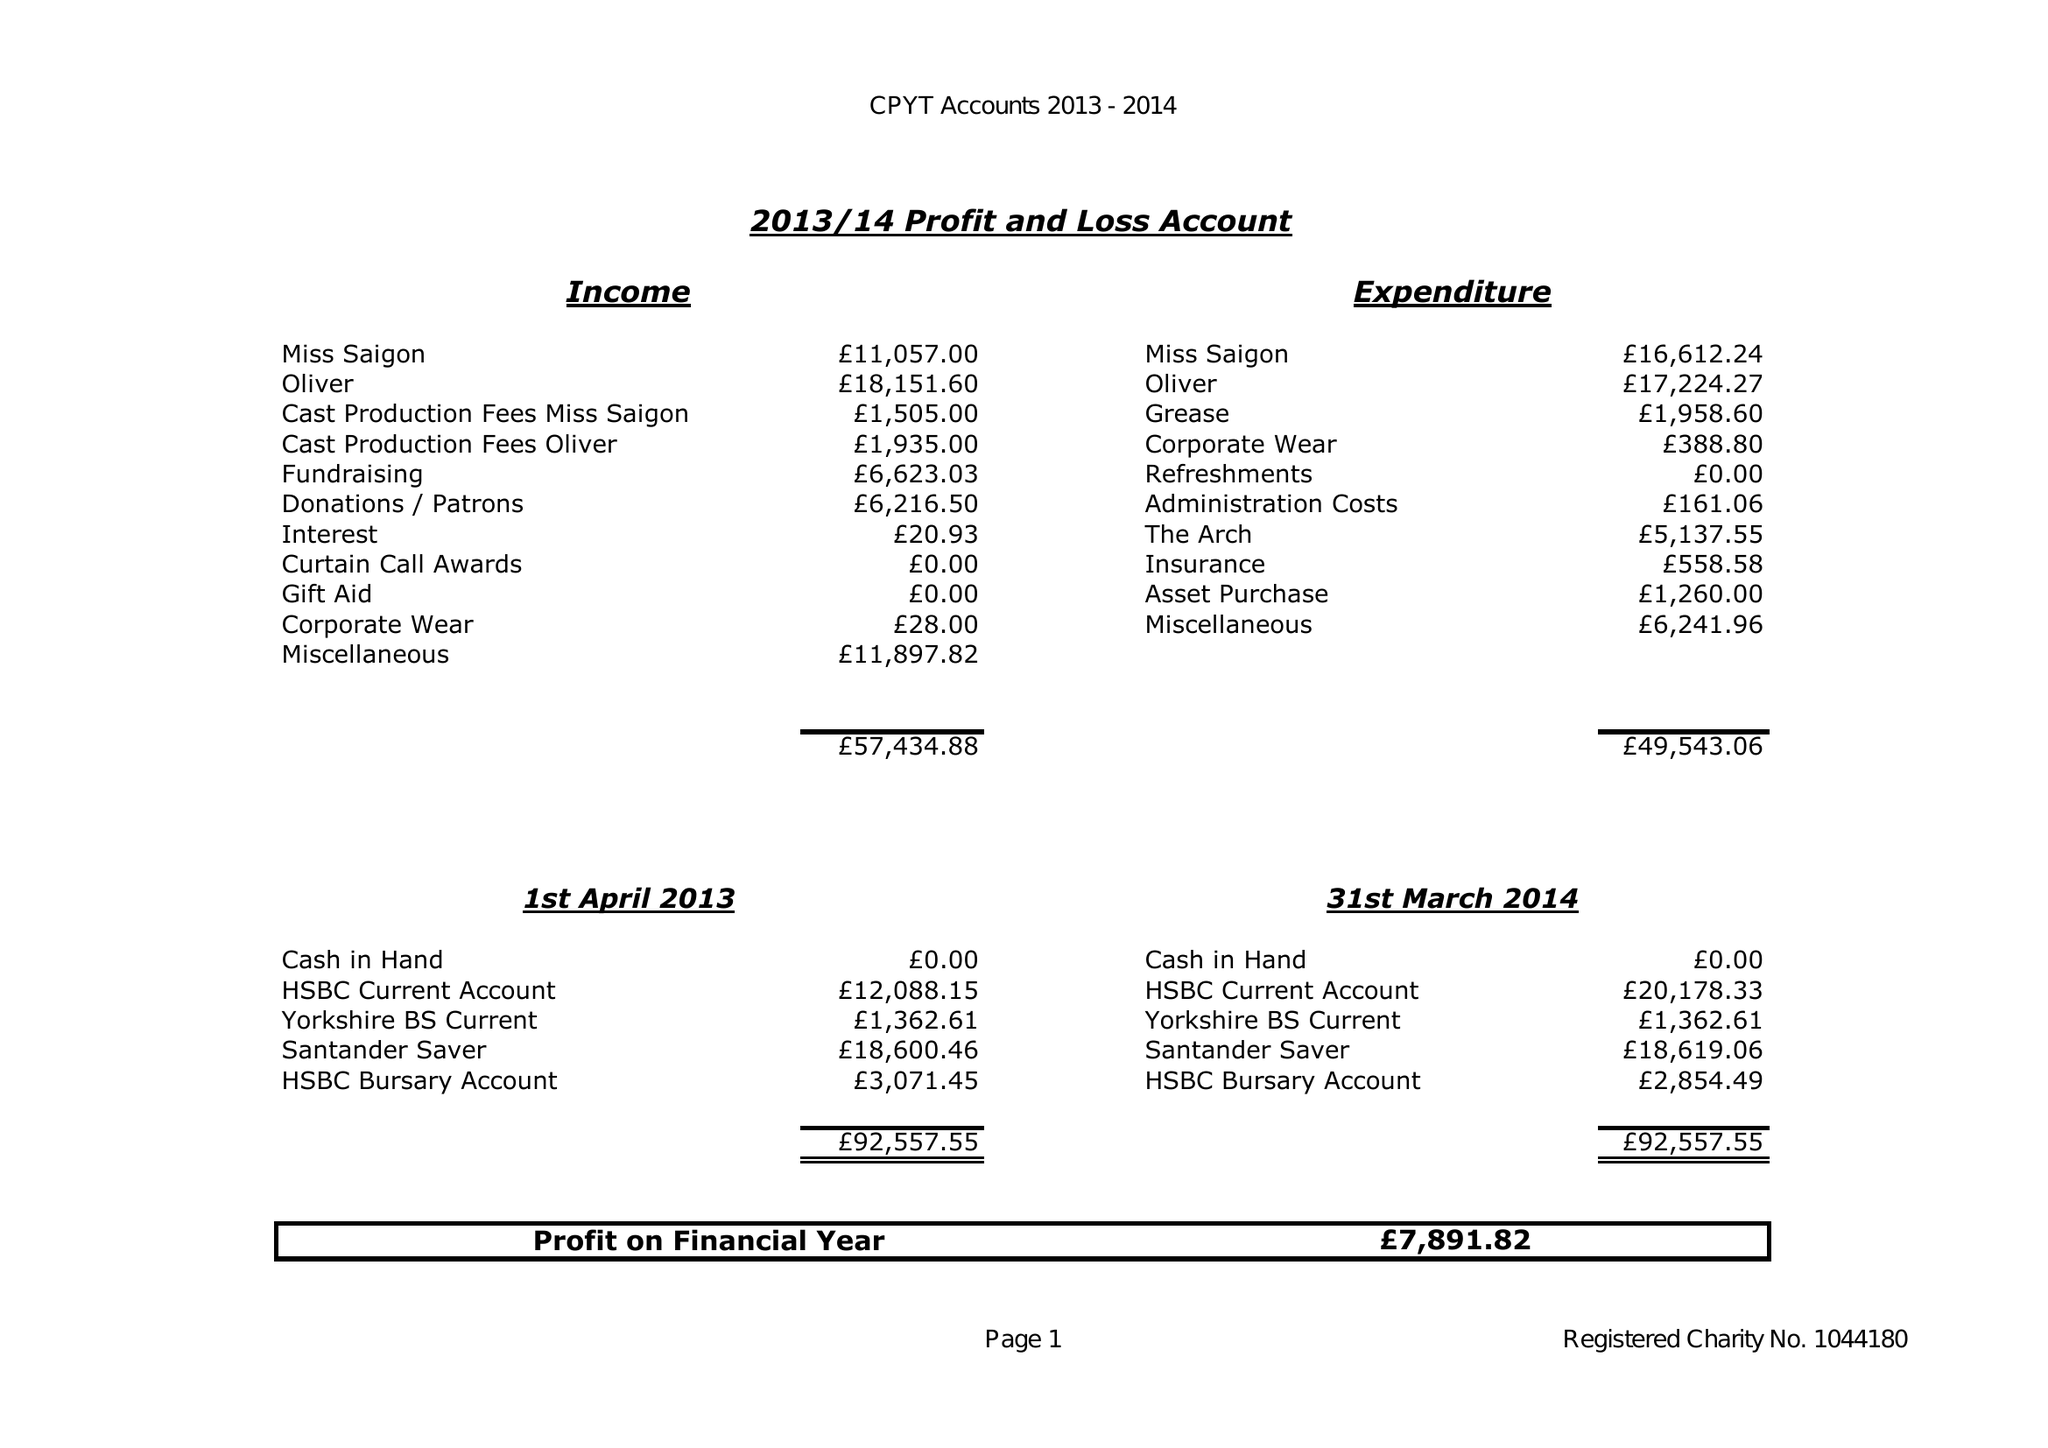What is the value for the income_annually_in_british_pounds?
Answer the question using a single word or phrase. 57435.00 